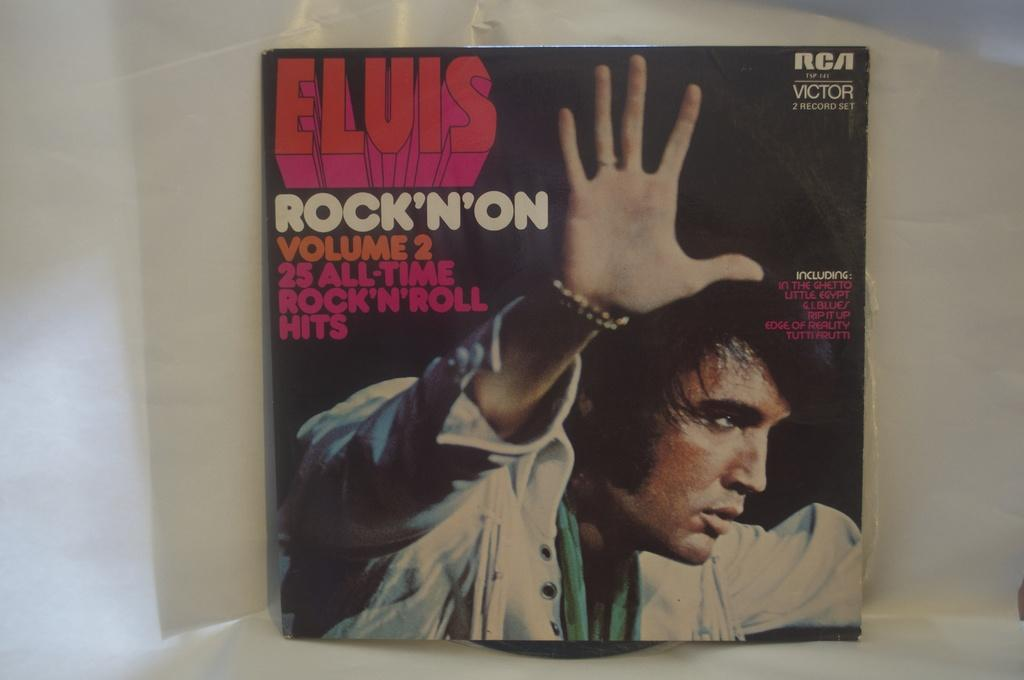<image>
Render a clear and concise summary of the photo. An Elvis Presley album features 25 all time rock and roll hits. 